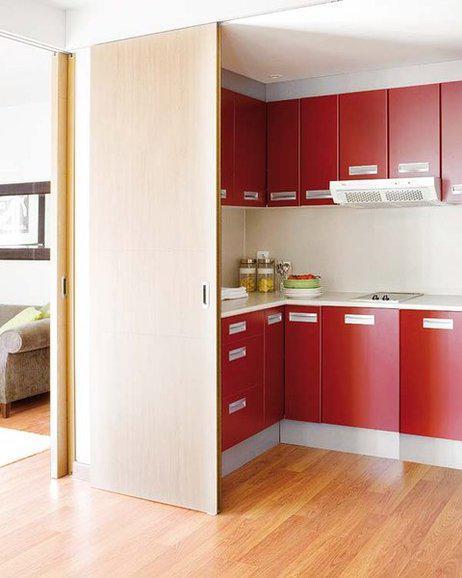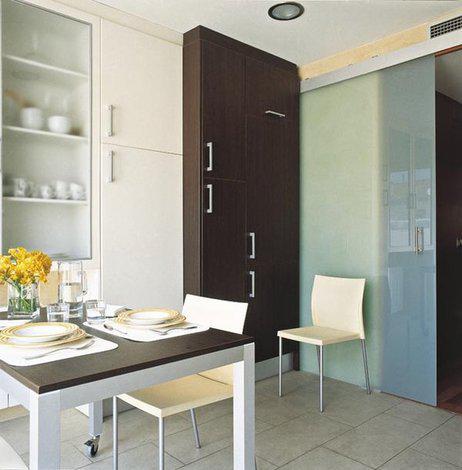The first image is the image on the left, the second image is the image on the right. For the images displayed, is the sentence "Chairs sit near a table in a home." factually correct? Answer yes or no. Yes. 